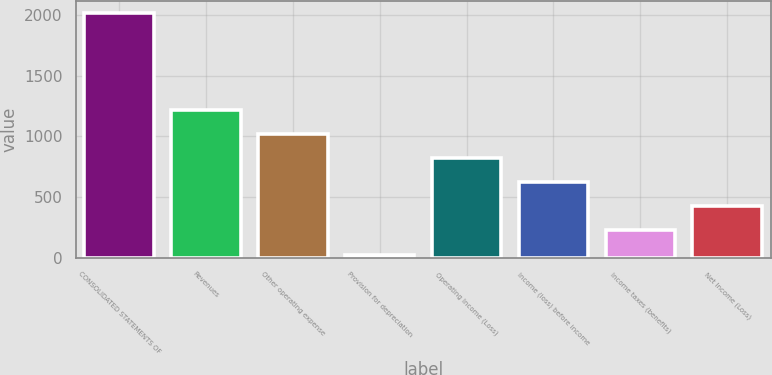Convert chart to OTSL. <chart><loc_0><loc_0><loc_500><loc_500><bar_chart><fcel>CONSOLIDATED STATEMENTS OF<fcel>Revenues<fcel>Other operating expense<fcel>Provision for depreciation<fcel>Operating Income (Loss)<fcel>Income (loss) before income<fcel>Income taxes (benefits)<fcel>Net Income (Loss)<nl><fcel>2012<fcel>1217.6<fcel>1019<fcel>26<fcel>820.4<fcel>621.8<fcel>224.6<fcel>423.2<nl></chart> 